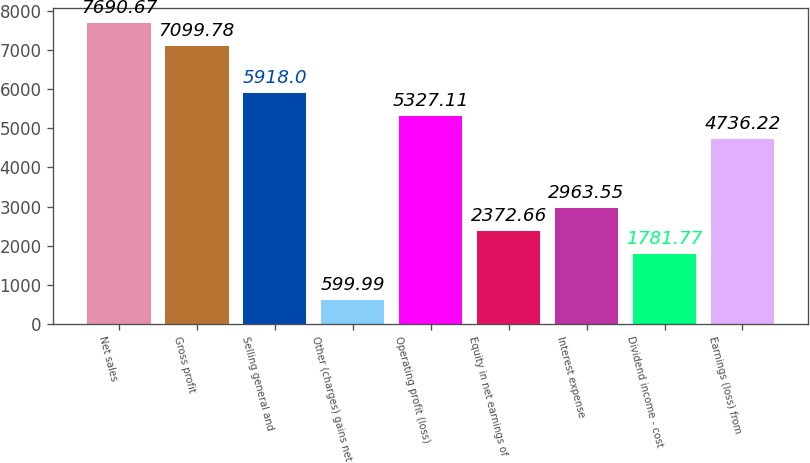Convert chart to OTSL. <chart><loc_0><loc_0><loc_500><loc_500><bar_chart><fcel>Net sales<fcel>Gross profit<fcel>Selling general and<fcel>Other (charges) gains net<fcel>Operating profit (loss)<fcel>Equity in net earnings of<fcel>Interest expense<fcel>Dividend income - cost<fcel>Earnings (loss) from<nl><fcel>7690.67<fcel>7099.78<fcel>5918<fcel>599.99<fcel>5327.11<fcel>2372.66<fcel>2963.55<fcel>1781.77<fcel>4736.22<nl></chart> 